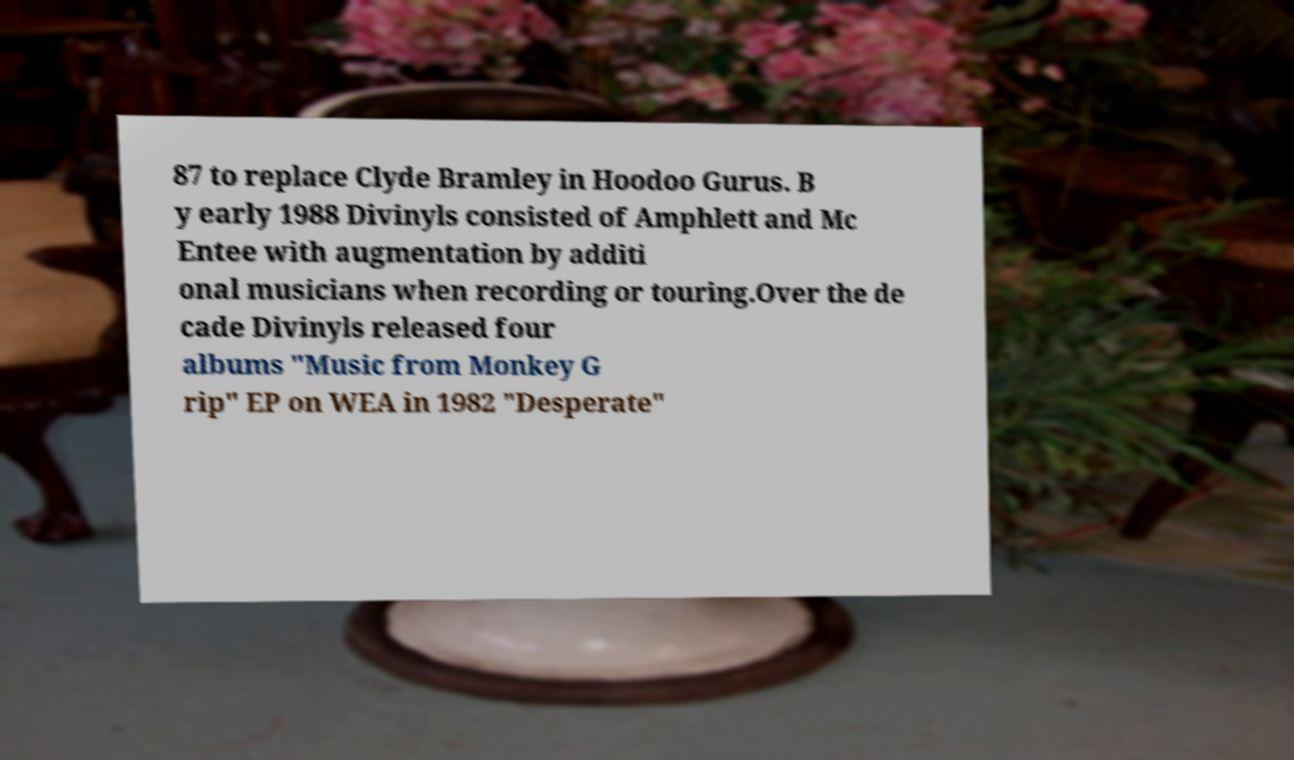Could you extract and type out the text from this image? 87 to replace Clyde Bramley in Hoodoo Gurus. B y early 1988 Divinyls consisted of Amphlett and Mc Entee with augmentation by additi onal musicians when recording or touring.Over the de cade Divinyls released four albums "Music from Monkey G rip" EP on WEA in 1982 "Desperate" 